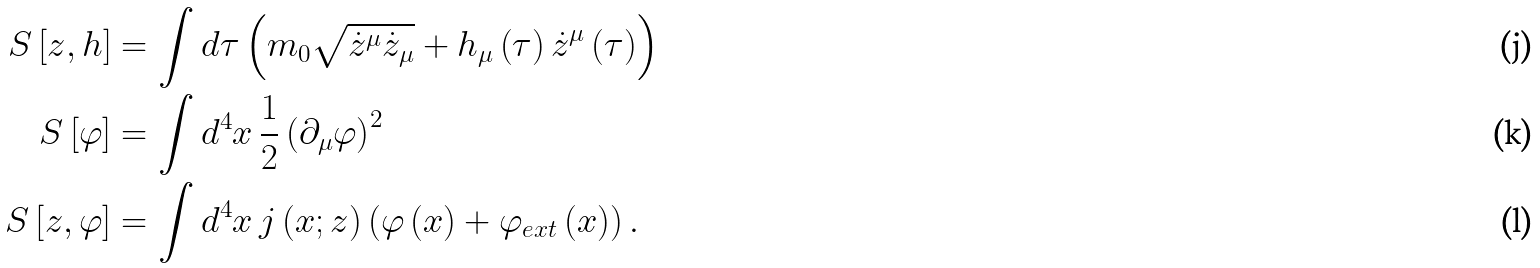<formula> <loc_0><loc_0><loc_500><loc_500>S \left [ z , h \right ] & = \int d \tau \left ( m _ { 0 } \sqrt { \dot { z } ^ { \mu } \dot { z } _ { \mu } } + h _ { \mu } \left ( \tau \right ) \dot { z } ^ { \mu } \left ( \tau \right ) \right ) \\ S \left [ \varphi \right ] & = \int d ^ { 4 } x \, \frac { 1 } { 2 } \left ( \partial _ { \mu } \varphi \right ) ^ { 2 } \\ S \left [ z , \varphi \right ] & = \int d ^ { 4 } x \, j \left ( x ; z \right ) \left ( \varphi \left ( x \right ) + \varphi _ { e x t } \left ( x \right ) \right ) .</formula> 